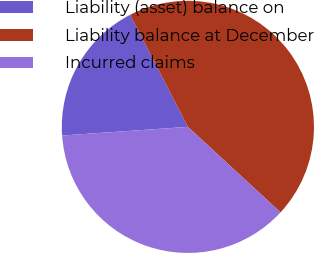Convert chart. <chart><loc_0><loc_0><loc_500><loc_500><pie_chart><fcel>Liability (asset) balance on<fcel>Liability balance at December<fcel>Incurred claims<nl><fcel>18.52%<fcel>44.44%<fcel>37.04%<nl></chart> 